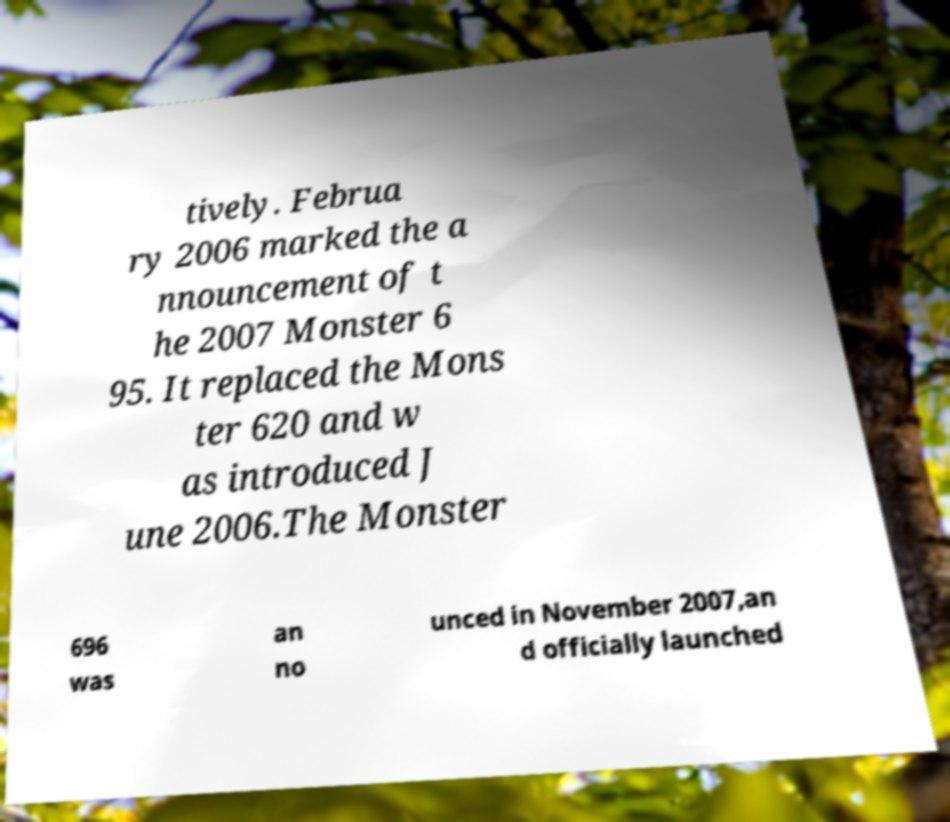Please read and relay the text visible in this image. What does it say? tively. Februa ry 2006 marked the a nnouncement of t he 2007 Monster 6 95. It replaced the Mons ter 620 and w as introduced J une 2006.The Monster 696 was an no unced in November 2007,an d officially launched 